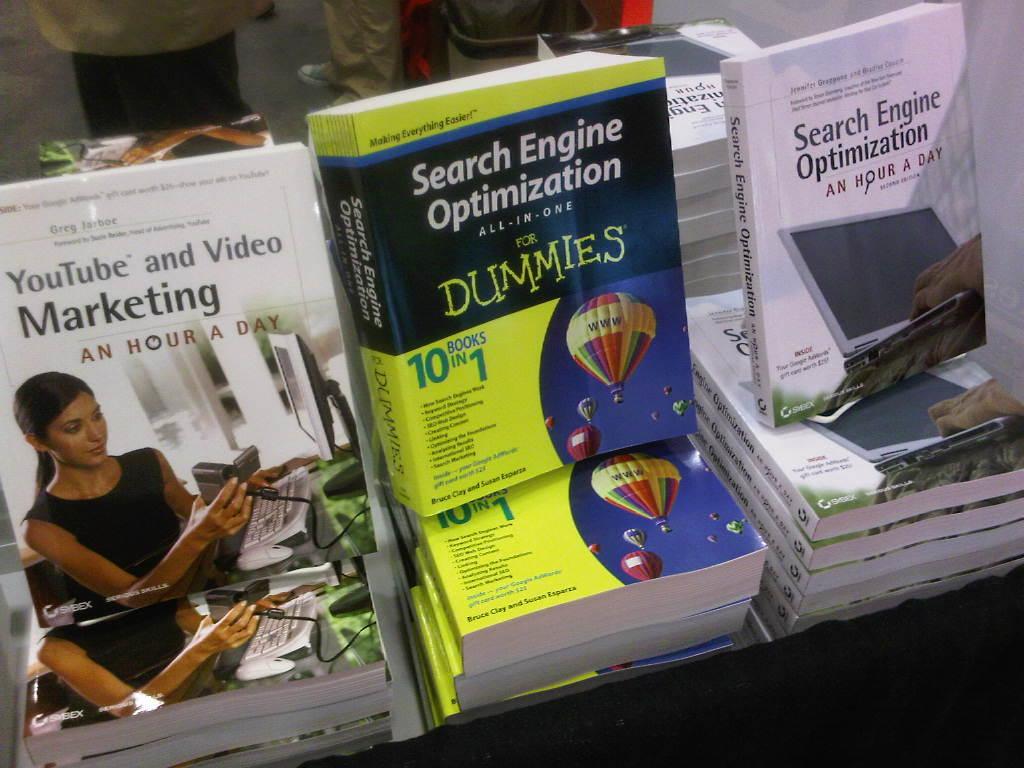What is the subject of the for dummies guide?
Provide a short and direct response. Search engine optimization. What is the title of the book?
Make the answer very short. Search engine optimization for dummies. 